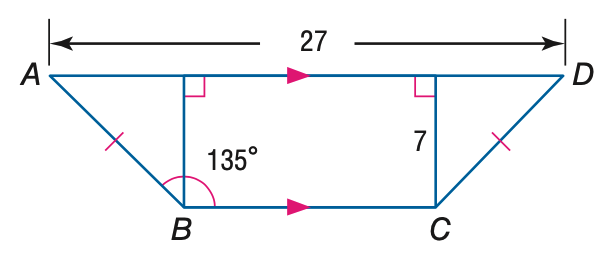Question: Find the perimeter of quadrilateral A B C D.
Choices:
A. 27 + 14 \sqrt { 2 }
B. 40 + 14 \sqrt { 2 }
C. 27 + 28 \sqrt { 2 }
D. 40 + 28 \sqrt { 2 }
Answer with the letter. Answer: B 